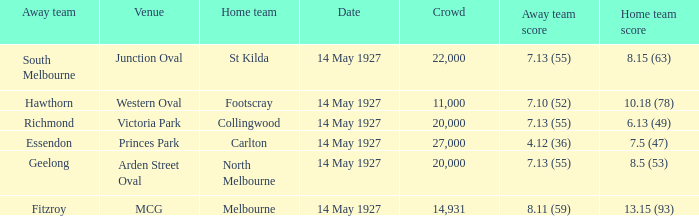Which away team had a score of 7.13 (55) against the home team North Melbourne? Geelong. 